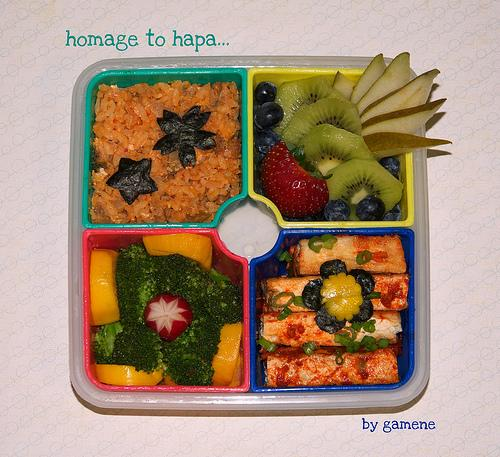Describe the image from the point of view of a nutritionist. This visually appealing platter showcases a variety of nutrient-rich foods, including fruits like kiwi and blueberries, vegetables such as broccoli and radish, and protein-rich tofu, all of which contribute to a well-balanced and nutritious meal. Describe the colors, patterns, and textures of the objects in the image. The image showcases a colorful assortment of foods, with the vibrant green of kiwi, the deep blue of blueberries, the bright red of strawberries, and the rich orange of mango, making the image vivid and appealing. Sum up the picture's content in just one sentence. The image features a container with various fruits, vegetables, tofu, and rice, neatly arranged into sections, each garnished artistically. Describe the image as if you were writing a review for a cooking show. This culinary presentation exemplifies a perfect balance of nutrition and aesthetics, featuring a vibrant array of fruits, vegetables, and tofu, each component thoughtfully prepared and beautifully presented to tantalize the taste buds and delight the senses. Explain the composition of the image as if you were teaching an art class. The photograph uses a harmonious color palette and effective placement of subjects, dividing the container into sections, each containing different food items like fruits, vegetables, tofu, and rice, and unified by artistic garnishes and a central placement of dipping sauce. Imagine you are giving a cooking workshop and have to describe the image to participants. In our next recipe, we will create a beautiful and colorful arrangement with an abundance of fruits, vegetables, tofu, and rice, all presented in a container divided into sections, as seen in the image, with each section garnished artistically. Briefly describe the image, focusing on the fruits and vegetables present. The image includes a container filled with strawberries, blueberries, kiwi, mango, radish, and broccoli, each section beautifully garnished and presented. Provide a short description of the contents of the image. The image displays various fruits, vegetables, tofu, and rice inside a container divided into sections, each beautifully garnished, including a central dipping sauce. Write a poetic description of the same image. A delectable display of nature's bounty lies within a vessel, where strawberries' rouge, blueberries' deep blue, kiwis' vivid green, and mango's bright orange all convene, alongside tofu and rice, to partake in a scrumptious feast. Imagine you are describing the image to someone who can't see it. Be specific about the details. In this image, there is a container filled with food items like strawberries, blueberries, kiwi, mango, rice, radish, and broccoli. There's a dipping sauce in the middle and each section is beautifully garnished. 